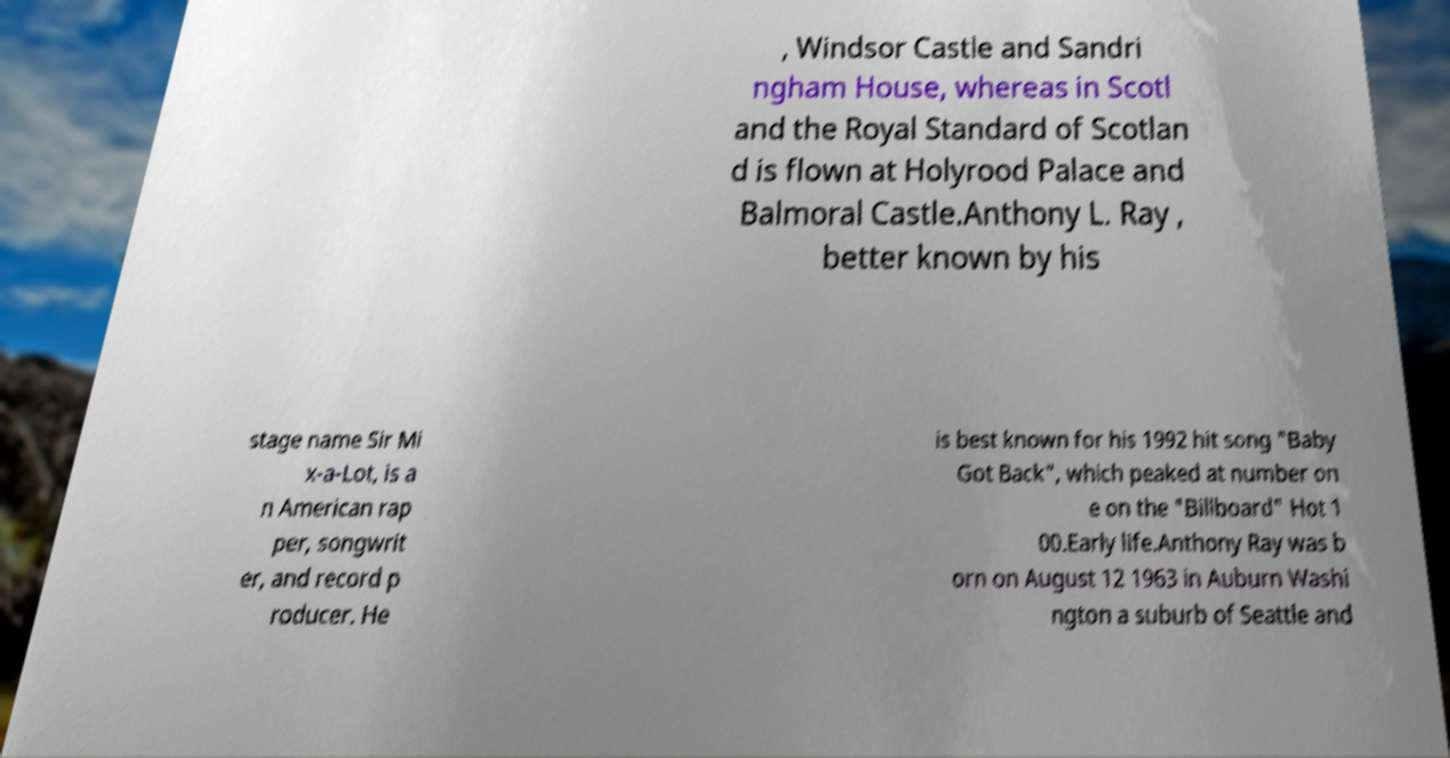Please identify and transcribe the text found in this image. , Windsor Castle and Sandri ngham House, whereas in Scotl and the Royal Standard of Scotlan d is flown at Holyrood Palace and Balmoral Castle.Anthony L. Ray , better known by his stage name Sir Mi x-a-Lot, is a n American rap per, songwrit er, and record p roducer. He is best known for his 1992 hit song "Baby Got Back", which peaked at number on e on the "Billboard" Hot 1 00.Early life.Anthony Ray was b orn on August 12 1963 in Auburn Washi ngton a suburb of Seattle and 